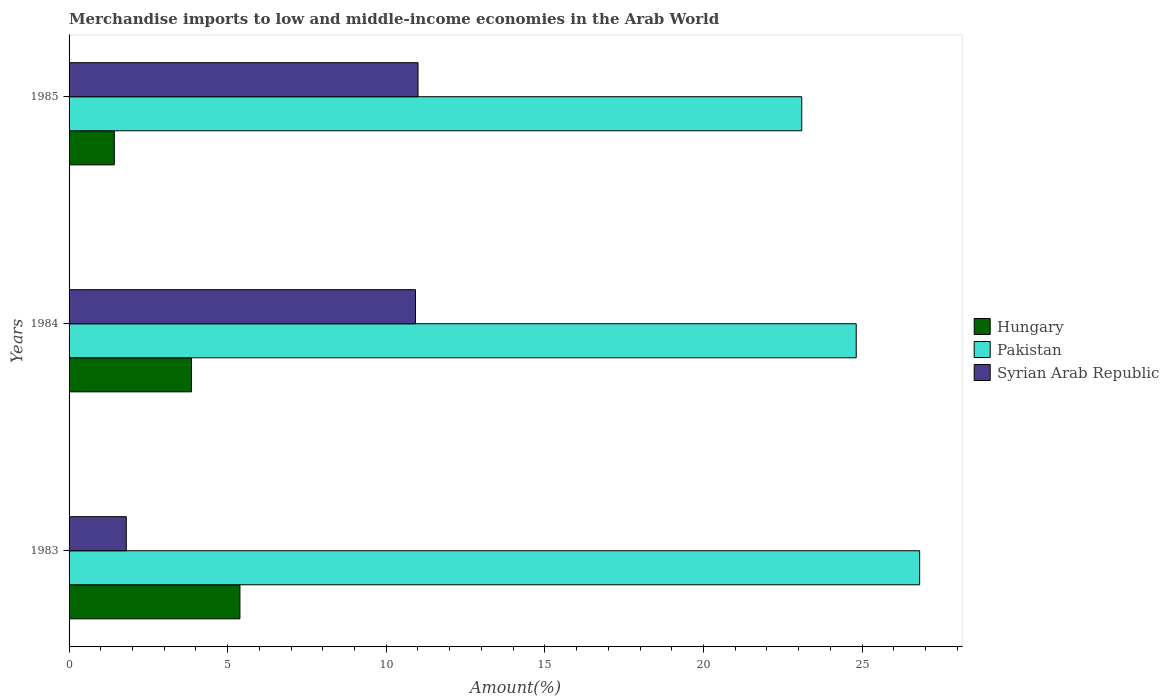Are the number of bars per tick equal to the number of legend labels?
Your answer should be very brief. Yes. What is the label of the 1st group of bars from the top?
Provide a succinct answer. 1985. What is the percentage of amount earned from merchandise imports in Hungary in 1983?
Your response must be concise. 5.39. Across all years, what is the maximum percentage of amount earned from merchandise imports in Hungary?
Keep it short and to the point. 5.39. Across all years, what is the minimum percentage of amount earned from merchandise imports in Syrian Arab Republic?
Keep it short and to the point. 1.8. In which year was the percentage of amount earned from merchandise imports in Pakistan maximum?
Provide a succinct answer. 1983. What is the total percentage of amount earned from merchandise imports in Hungary in the graph?
Offer a terse response. 10.67. What is the difference between the percentage of amount earned from merchandise imports in Pakistan in 1984 and that in 1985?
Give a very brief answer. 1.72. What is the difference between the percentage of amount earned from merchandise imports in Hungary in 1983 and the percentage of amount earned from merchandise imports in Syrian Arab Republic in 1984?
Your response must be concise. -5.53. What is the average percentage of amount earned from merchandise imports in Syrian Arab Republic per year?
Provide a short and direct response. 7.91. In the year 1985, what is the difference between the percentage of amount earned from merchandise imports in Syrian Arab Republic and percentage of amount earned from merchandise imports in Pakistan?
Give a very brief answer. -12.1. In how many years, is the percentage of amount earned from merchandise imports in Pakistan greater than 12 %?
Your response must be concise. 3. What is the ratio of the percentage of amount earned from merchandise imports in Syrian Arab Republic in 1983 to that in 1984?
Your answer should be very brief. 0.17. Is the difference between the percentage of amount earned from merchandise imports in Syrian Arab Republic in 1983 and 1985 greater than the difference between the percentage of amount earned from merchandise imports in Pakistan in 1983 and 1985?
Offer a terse response. No. What is the difference between the highest and the second highest percentage of amount earned from merchandise imports in Pakistan?
Provide a succinct answer. 2. What is the difference between the highest and the lowest percentage of amount earned from merchandise imports in Pakistan?
Provide a succinct answer. 3.72. Is the sum of the percentage of amount earned from merchandise imports in Syrian Arab Republic in 1984 and 1985 greater than the maximum percentage of amount earned from merchandise imports in Hungary across all years?
Give a very brief answer. Yes. What does the 1st bar from the top in 1984 represents?
Your answer should be very brief. Syrian Arab Republic. Are all the bars in the graph horizontal?
Keep it short and to the point. Yes. What is the title of the graph?
Ensure brevity in your answer.  Merchandise imports to low and middle-income economies in the Arab World. Does "Korea (Republic)" appear as one of the legend labels in the graph?
Ensure brevity in your answer.  No. What is the label or title of the X-axis?
Offer a terse response. Amount(%). What is the label or title of the Y-axis?
Provide a succinct answer. Years. What is the Amount(%) in Hungary in 1983?
Offer a very short reply. 5.39. What is the Amount(%) of Pakistan in 1983?
Offer a terse response. 26.82. What is the Amount(%) of Syrian Arab Republic in 1983?
Offer a terse response. 1.8. What is the Amount(%) of Hungary in 1984?
Provide a succinct answer. 3.86. What is the Amount(%) of Pakistan in 1984?
Offer a very short reply. 24.82. What is the Amount(%) in Syrian Arab Republic in 1984?
Offer a very short reply. 10.92. What is the Amount(%) in Hungary in 1985?
Your response must be concise. 1.43. What is the Amount(%) of Pakistan in 1985?
Offer a terse response. 23.1. What is the Amount(%) in Syrian Arab Republic in 1985?
Your response must be concise. 11. Across all years, what is the maximum Amount(%) of Hungary?
Offer a terse response. 5.39. Across all years, what is the maximum Amount(%) in Pakistan?
Give a very brief answer. 26.82. Across all years, what is the maximum Amount(%) of Syrian Arab Republic?
Provide a short and direct response. 11. Across all years, what is the minimum Amount(%) of Hungary?
Your response must be concise. 1.43. Across all years, what is the minimum Amount(%) in Pakistan?
Keep it short and to the point. 23.1. Across all years, what is the minimum Amount(%) of Syrian Arab Republic?
Your answer should be very brief. 1.8. What is the total Amount(%) of Hungary in the graph?
Provide a short and direct response. 10.67. What is the total Amount(%) in Pakistan in the graph?
Keep it short and to the point. 74.73. What is the total Amount(%) of Syrian Arab Republic in the graph?
Make the answer very short. 23.73. What is the difference between the Amount(%) of Hungary in 1983 and that in 1984?
Provide a short and direct response. 1.53. What is the difference between the Amount(%) of Pakistan in 1983 and that in 1984?
Your response must be concise. 2. What is the difference between the Amount(%) in Syrian Arab Republic in 1983 and that in 1984?
Your answer should be very brief. -9.12. What is the difference between the Amount(%) in Hungary in 1983 and that in 1985?
Make the answer very short. 3.96. What is the difference between the Amount(%) in Pakistan in 1983 and that in 1985?
Provide a succinct answer. 3.72. What is the difference between the Amount(%) of Syrian Arab Republic in 1983 and that in 1985?
Offer a very short reply. -9.2. What is the difference between the Amount(%) of Hungary in 1984 and that in 1985?
Give a very brief answer. 2.43. What is the difference between the Amount(%) of Pakistan in 1984 and that in 1985?
Give a very brief answer. 1.72. What is the difference between the Amount(%) in Syrian Arab Republic in 1984 and that in 1985?
Your response must be concise. -0.08. What is the difference between the Amount(%) of Hungary in 1983 and the Amount(%) of Pakistan in 1984?
Give a very brief answer. -19.43. What is the difference between the Amount(%) in Hungary in 1983 and the Amount(%) in Syrian Arab Republic in 1984?
Provide a succinct answer. -5.53. What is the difference between the Amount(%) of Pakistan in 1983 and the Amount(%) of Syrian Arab Republic in 1984?
Your response must be concise. 15.89. What is the difference between the Amount(%) of Hungary in 1983 and the Amount(%) of Pakistan in 1985?
Provide a short and direct response. -17.71. What is the difference between the Amount(%) of Hungary in 1983 and the Amount(%) of Syrian Arab Republic in 1985?
Your answer should be very brief. -5.61. What is the difference between the Amount(%) of Pakistan in 1983 and the Amount(%) of Syrian Arab Republic in 1985?
Provide a short and direct response. 15.81. What is the difference between the Amount(%) in Hungary in 1984 and the Amount(%) in Pakistan in 1985?
Provide a short and direct response. -19.24. What is the difference between the Amount(%) of Hungary in 1984 and the Amount(%) of Syrian Arab Republic in 1985?
Give a very brief answer. -7.14. What is the difference between the Amount(%) of Pakistan in 1984 and the Amount(%) of Syrian Arab Republic in 1985?
Provide a short and direct response. 13.82. What is the average Amount(%) in Hungary per year?
Make the answer very short. 3.56. What is the average Amount(%) in Pakistan per year?
Your answer should be very brief. 24.91. What is the average Amount(%) in Syrian Arab Republic per year?
Your answer should be very brief. 7.91. In the year 1983, what is the difference between the Amount(%) of Hungary and Amount(%) of Pakistan?
Your response must be concise. -21.43. In the year 1983, what is the difference between the Amount(%) in Hungary and Amount(%) in Syrian Arab Republic?
Offer a very short reply. 3.58. In the year 1983, what is the difference between the Amount(%) in Pakistan and Amount(%) in Syrian Arab Republic?
Make the answer very short. 25.01. In the year 1984, what is the difference between the Amount(%) of Hungary and Amount(%) of Pakistan?
Give a very brief answer. -20.96. In the year 1984, what is the difference between the Amount(%) of Hungary and Amount(%) of Syrian Arab Republic?
Your response must be concise. -7.06. In the year 1984, what is the difference between the Amount(%) in Pakistan and Amount(%) in Syrian Arab Republic?
Provide a short and direct response. 13.89. In the year 1985, what is the difference between the Amount(%) of Hungary and Amount(%) of Pakistan?
Your answer should be compact. -21.67. In the year 1985, what is the difference between the Amount(%) in Hungary and Amount(%) in Syrian Arab Republic?
Provide a succinct answer. -9.57. In the year 1985, what is the difference between the Amount(%) in Pakistan and Amount(%) in Syrian Arab Republic?
Make the answer very short. 12.1. What is the ratio of the Amount(%) in Hungary in 1983 to that in 1984?
Provide a short and direct response. 1.4. What is the ratio of the Amount(%) in Pakistan in 1983 to that in 1984?
Provide a short and direct response. 1.08. What is the ratio of the Amount(%) in Syrian Arab Republic in 1983 to that in 1984?
Provide a short and direct response. 0.17. What is the ratio of the Amount(%) of Hungary in 1983 to that in 1985?
Make the answer very short. 3.78. What is the ratio of the Amount(%) of Pakistan in 1983 to that in 1985?
Give a very brief answer. 1.16. What is the ratio of the Amount(%) of Syrian Arab Republic in 1983 to that in 1985?
Give a very brief answer. 0.16. What is the ratio of the Amount(%) of Hungary in 1984 to that in 1985?
Make the answer very short. 2.71. What is the ratio of the Amount(%) of Pakistan in 1984 to that in 1985?
Your response must be concise. 1.07. What is the ratio of the Amount(%) in Syrian Arab Republic in 1984 to that in 1985?
Offer a very short reply. 0.99. What is the difference between the highest and the second highest Amount(%) of Hungary?
Offer a terse response. 1.53. What is the difference between the highest and the second highest Amount(%) in Pakistan?
Give a very brief answer. 2. What is the difference between the highest and the second highest Amount(%) of Syrian Arab Republic?
Give a very brief answer. 0.08. What is the difference between the highest and the lowest Amount(%) in Hungary?
Offer a very short reply. 3.96. What is the difference between the highest and the lowest Amount(%) of Pakistan?
Your answer should be very brief. 3.72. What is the difference between the highest and the lowest Amount(%) of Syrian Arab Republic?
Offer a terse response. 9.2. 